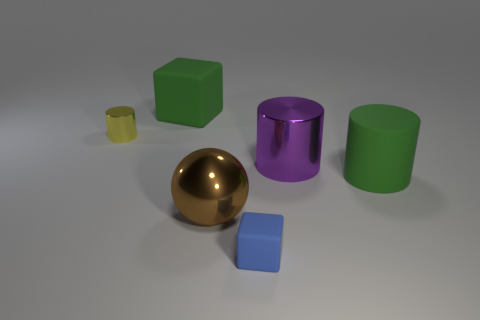Subtract all green cylinders. How many cylinders are left? 2 Subtract all blue cubes. How many cubes are left? 1 Subtract 1 cubes. How many cubes are left? 1 Add 1 big blue rubber spheres. How many objects exist? 7 Subtract all balls. How many objects are left? 5 Subtract all yellow balls. Subtract all cyan blocks. How many balls are left? 1 Subtract all cyan spheres. How many green cylinders are left? 1 Subtract all big green things. Subtract all large gray objects. How many objects are left? 4 Add 5 blue blocks. How many blue blocks are left? 6 Add 3 small yellow balls. How many small yellow balls exist? 3 